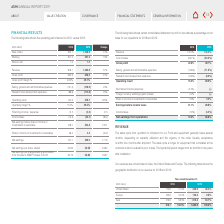According to Asm International Nv's financial document, Where are the revenues of this company concentrated? Asia, the United States and Europe. The document states: "Our revenues are concentrated in Asia, the United States and Europe. The following table shows the..." Also, What is the usual acceptance duration after shipment? According to the financial document, within four months. The relevant text states: "is within four months after shipment. The sales cycle is longer for equipment that is installed at the..." Also, What is the base currency used for the table? According to the financial document, EUR. The relevant text states: "(EUR million) 2018 2019 Change..." Also, can you calculate: What is the average revenue for United States in 2018 and 2019? To answer this question, I need to perform calculations using the financial data. The calculation is: (175.9+339.5)/2, which equals 257.7 (in millions). This is based on the information: "United States 175.9 21.5% 339.5 26.4% United States 175.9 21.5% 339.5 26.4%..." The key data points involved are: 175.9, 339.5. Also, can you calculate: How much more revenue does the company have in Asia have over Europe for 2019? Based on the calculation: 818.2-126.2, the result is 692 (in millions). This is based on the information: "Europe 165.6 20.2% 126.2 9.8% Asia 476.6 58.3% 818.2 63.7%..." The key data points involved are: 126.2, 818.2. Also, can you calculate: What is the average annual total revenue for all regions for 2018 and 2019? To answer this question, I need to perform calculations using the financial data. The calculation is: (818.1+1,283.9)/2, which equals 1051 (in millions). This is based on the information: "818.1 100.0% 1,283.9 100.0% 818.1 100.0% 1,283.9 100.0%..." The key data points involved are: 1,283.9, 818.1. 